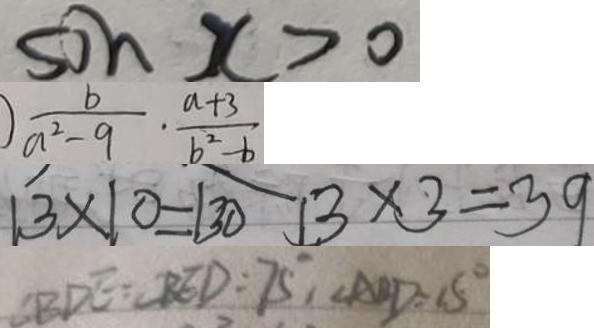Convert formula to latex. <formula><loc_0><loc_0><loc_500><loc_500>\sin x > 0 
 \frac { b } { a ^ { 2 } - 9 } \cdot \frac { a + 3 } { b ^ { 2 } - b } 
 1 3 \times 1 0 - 1 3 0 1 3 \times 3 = 3 9 
 \angle B D E = B E D = 7 5 ^ { \circ } , \angle A B D = 1 5 ^ { \circ }</formula> 